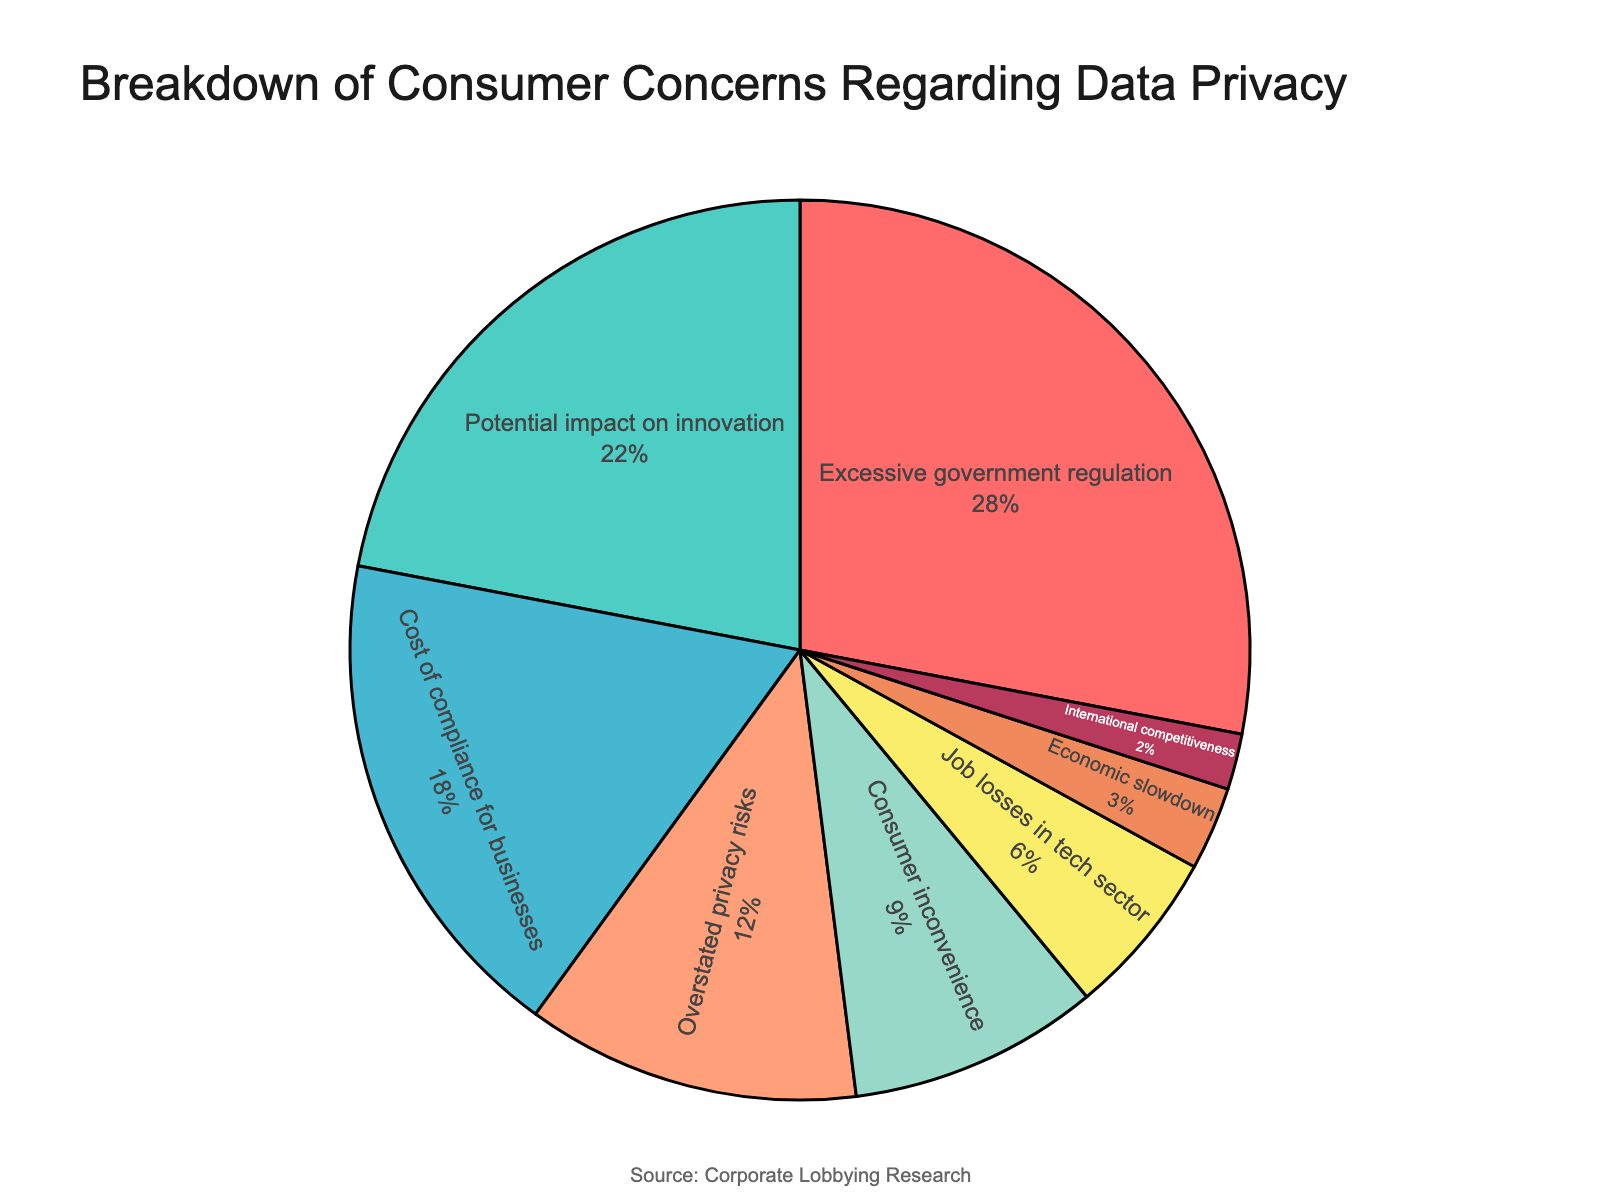What category is the most concerning for consumers regarding data privacy? The largest segment in the pie chart represents "Excessive government regulation."
Answer: Excessive government regulation Which categories combined account for exactly half of consumer concerns? Combining "Excessive government regulation" (28%) and "Potential impact on innovation" (22%) sums to 50%, which represents half of the total concerns.
Answer: Excessive government regulation and Potential impact on innovation Which concern is reflected in the smallest segment of the pie chart? The smallest slice of the pie chart corresponds to "International competitiveness" at 2%.
Answer: International competitiveness How much higher is the concern for "Excessive government regulation" compared to "Cost of compliance for businesses"? The concern for "Excessive government regulation" is 28%, whereas "Cost of compliance for businesses" is 18%. The difference is 28% - 18% = 10%.
Answer: 10% What percentage of concerns fall under categories that are perceived to impact the economy (e.g., job losses, economic slowdown, and international competitiveness)? Adding the percentages for "Job losses in tech sector" (6%), "Economic slowdown" (3%), and "International competitiveness" (2%) gives 6% + 3% + 2% = 11%.
Answer: 11% Which colors correspond to the "Cost of compliance for businesses" and "Potential impact on innovation" categories respectively? "Cost of compliance for businesses" is represented by a greenish color, and "Potential impact on innovation" is in turquoise.
Answer: Greenish (teal) and turquoise Which concern do consumers worry about more: "Overstated privacy risks" or "Consumer inconvenience"? "Overstated privacy risks" is 12%, whereas "Consumer inconvenience" is 9%. 12% is greater than 9%.
Answer: Overstated privacy risks If we group the concerns into three major categories: regulations (including excessive government regulation and cost of compliance), technology impact (including potential impact on innovation and job losses in tech sector), and other, what percentage do each group represent? 1. Regulations: "Excessive government regulation" (28%) + "Cost of compliance for businesses" (18%) = 46%.
2. Technology impact: "Potential impact on innovation" (22%) + "Job losses in tech sector" (6%) = 28%.
3. Other: "Overstated privacy risks" (12%) + "Consumer inconvenience" (9%) + "Economic slowdown" (3%) + "International competitiveness" (2%) = 26%.
Answer: Regulations: 46%, Technology impact: 28%, Other: 26% What is the combined percentage of concerns related to "Overstated privacy risks" and "Consumer inconvenience"? Adding the percentages for "Overstated privacy risks" (12%) and "Consumer inconvenience" (9%) results in 12% + 9% = 21%.
Answer: 21% 